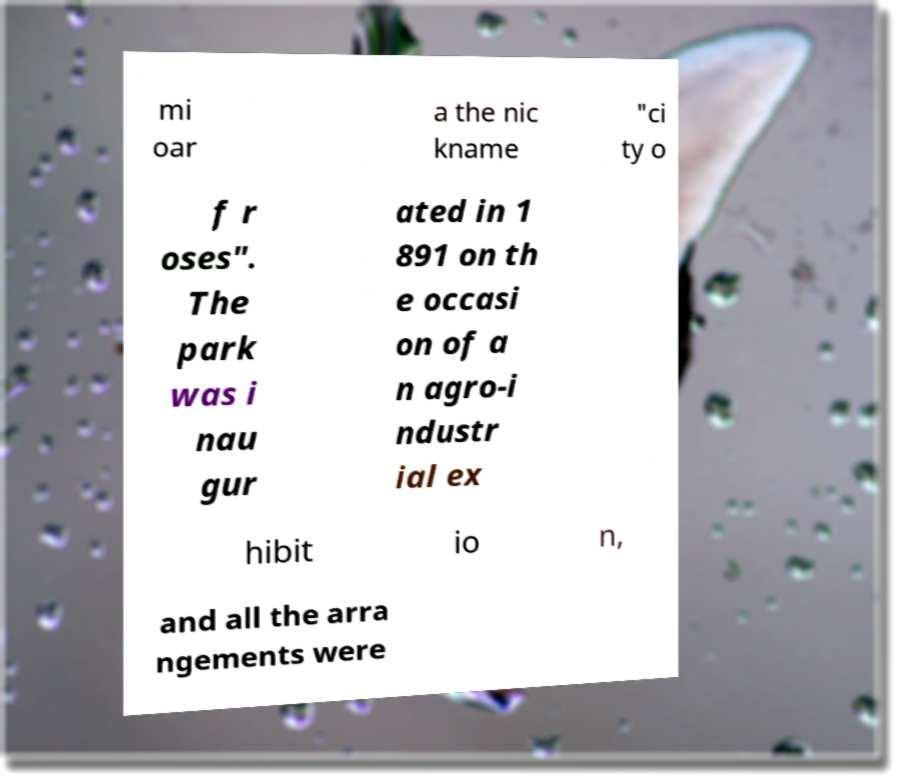Could you extract and type out the text from this image? mi oar a the nic kname "ci ty o f r oses". The park was i nau gur ated in 1 891 on th e occasi on of a n agro-i ndustr ial ex hibit io n, and all the arra ngements were 